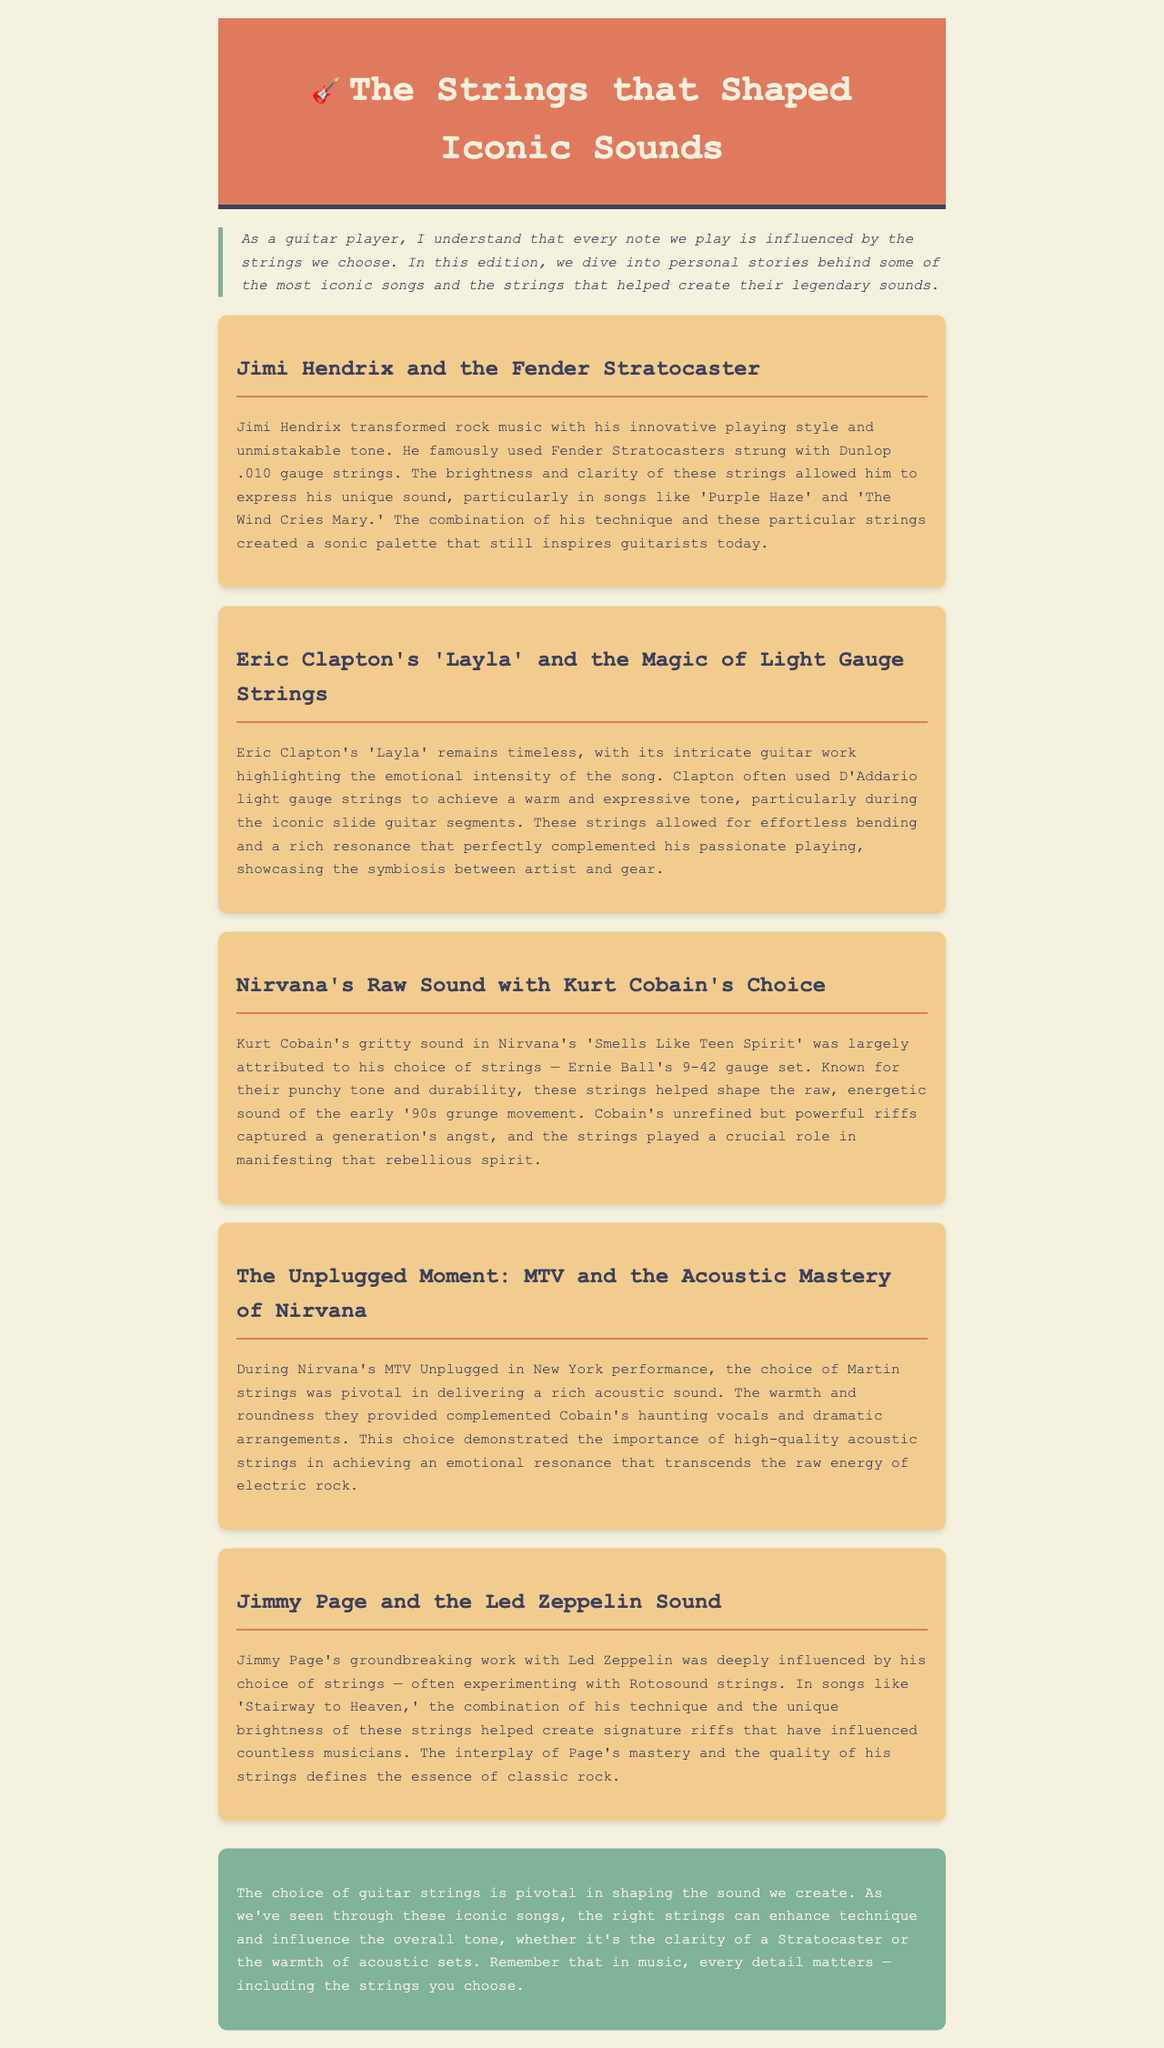what gauge strings did Jimi Hendrix use? The document states that Jimi Hendrix used Dunlop .010 gauge strings.
Answer: Dunlop .010 gauge strings which song is associated with Eric Clapton's use of light gauge strings? The song 'Layla' is specifically mentioned in connection with Eric Clapton's use of light gauge strings.
Answer: 'Layla' what brand of strings did Kurt Cobain prefer for Nirvana? The document indicates that Kurt Cobain used Ernie Ball's 9-42 gauge set.
Answer: Ernie Ball how did Martin strings contribute to Nirvana's MTV Unplugged performance? It is noted that Martin strings helped deliver a rich acoustic sound during Nirvana's MTV Unplugged performance.
Answer: Deliver a rich acoustic sound which iconic song features Jimmy Page's signature riffs? The document mentions 'Stairway to Heaven' showcasing Jimmy Page's signature riffs.
Answer: 'Stairway to Heaven' what is the central theme of this newsletter? The newsletter emphasizes the pivotal role of guitar strings in shaping sound and enhancing technique in music.
Answer: The pivotal role of guitar strings in shaping sound how many stories are included in the document? The document features a total of five personal stories about iconic songs and their associated strings.
Answer: Five stories 